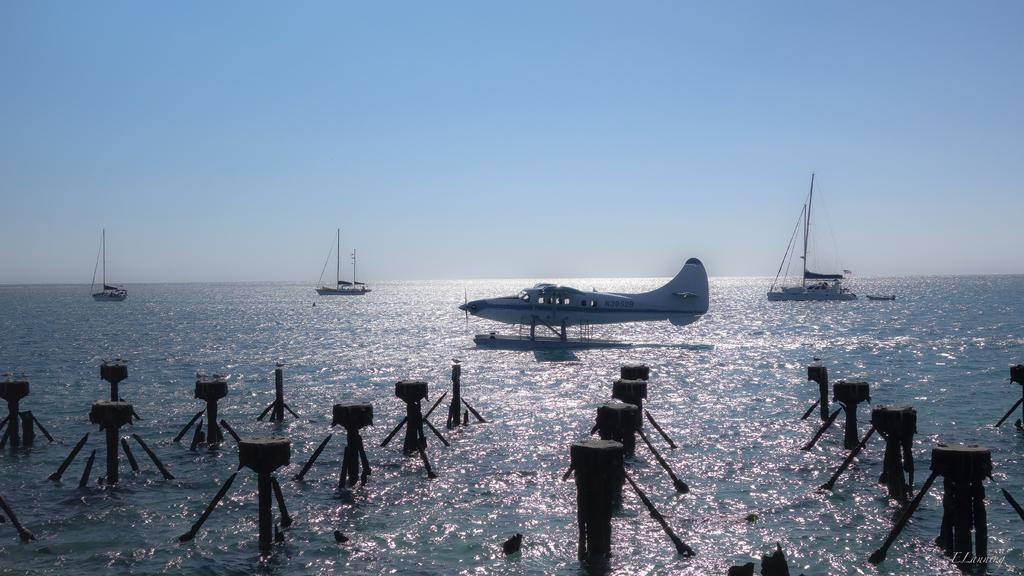Describe this image in one or two sentences. Above this water there are boats and plane. Sky is in blue color. 